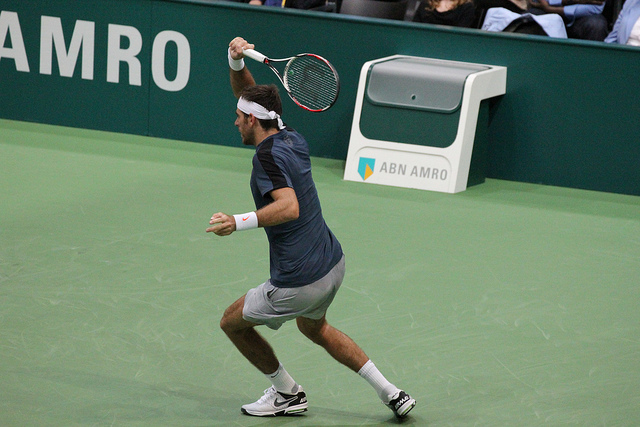What bank is a sponsor of the tennis event? Based on the visible signage in the image, the sponsor of the tennis event is ABN AMRO. This bank's name is displayed on signs around the court, indicating their sponsorship. 